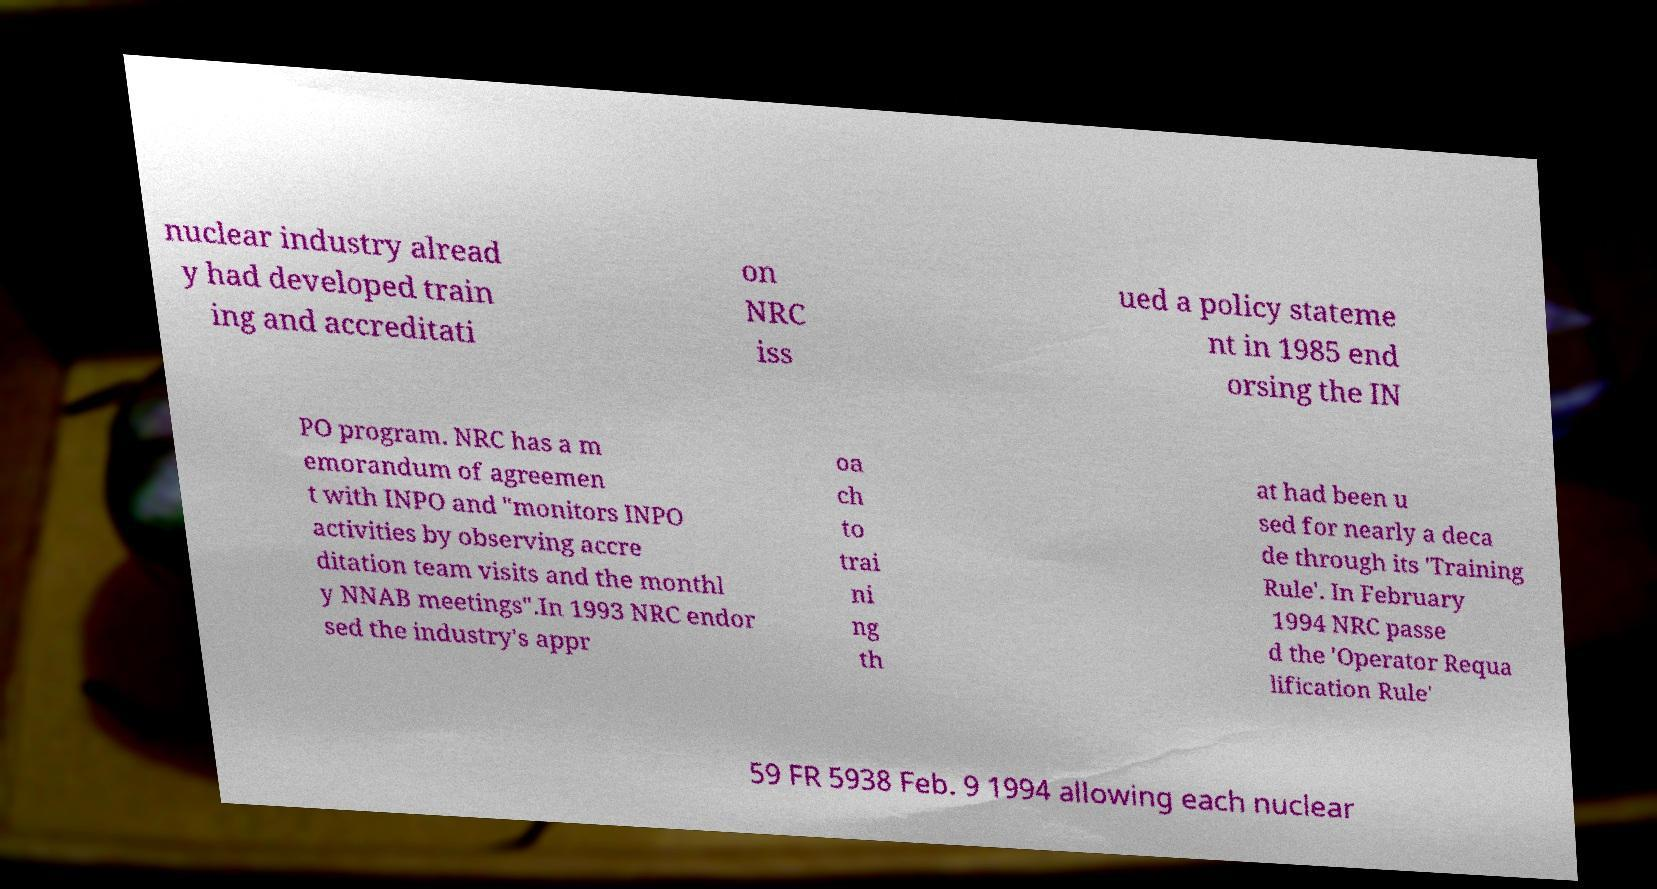Can you read and provide the text displayed in the image?This photo seems to have some interesting text. Can you extract and type it out for me? nuclear industry alread y had developed train ing and accreditati on NRC iss ued a policy stateme nt in 1985 end orsing the IN PO program. NRC has a m emorandum of agreemen t with INPO and "monitors INPO activities by observing accre ditation team visits and the monthl y NNAB meetings".In 1993 NRC endor sed the industry's appr oa ch to trai ni ng th at had been u sed for nearly a deca de through its 'Training Rule'. In February 1994 NRC passe d the 'Operator Requa lification Rule' 59 FR 5938 Feb. 9 1994 allowing each nuclear 